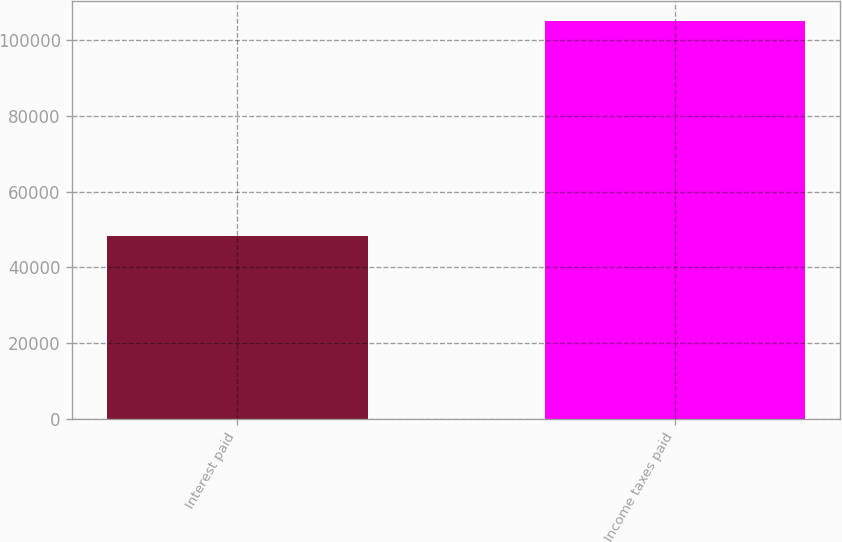Convert chart to OTSL. <chart><loc_0><loc_0><loc_500><loc_500><bar_chart><fcel>Interest paid<fcel>Income taxes paid<nl><fcel>48272<fcel>105100<nl></chart> 